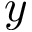Convert formula to latex. <formula><loc_0><loc_0><loc_500><loc_500>y</formula> 